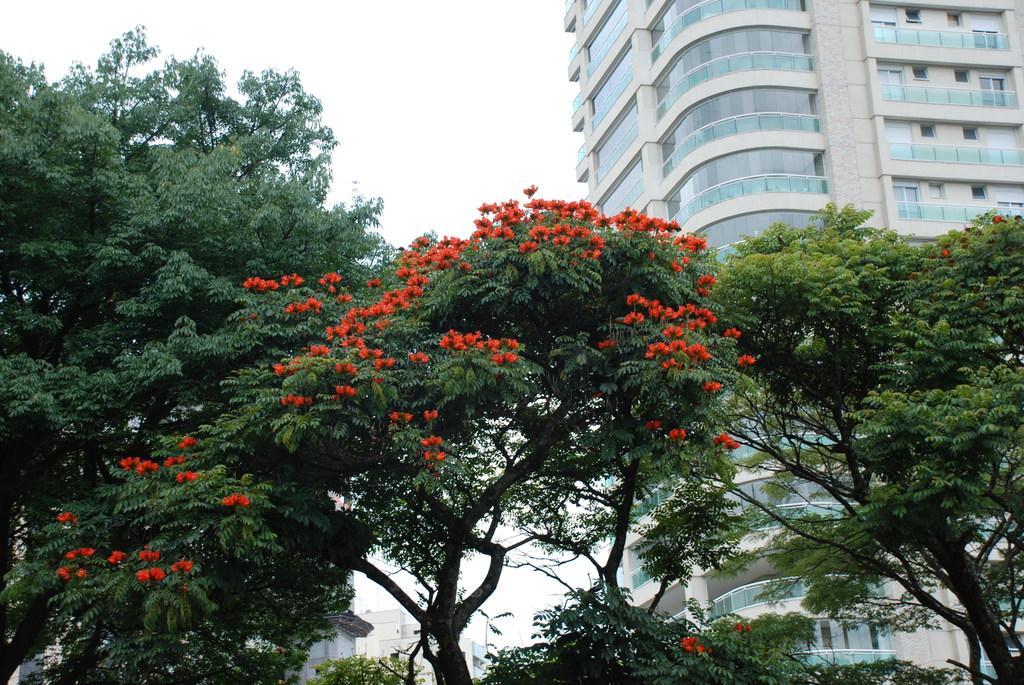In one or two sentences, can you explain what this image depicts? This is an outside view. At the bottom there are some trees and also I can see red color flowers to a tree. In the background there are few buildings. At the top of the image I can see the sky. 